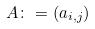<formula> <loc_0><loc_0><loc_500><loc_500>A \colon = ( a _ { i , j } )</formula> 